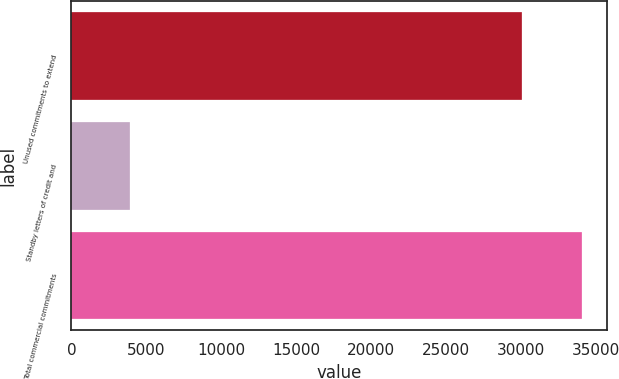<chart> <loc_0><loc_0><loc_500><loc_500><bar_chart><fcel>Unused commitments to extend<fcel>Standby letters of credit and<fcel>Total commercial commitments<nl><fcel>30056<fcel>3881<fcel>34017<nl></chart> 